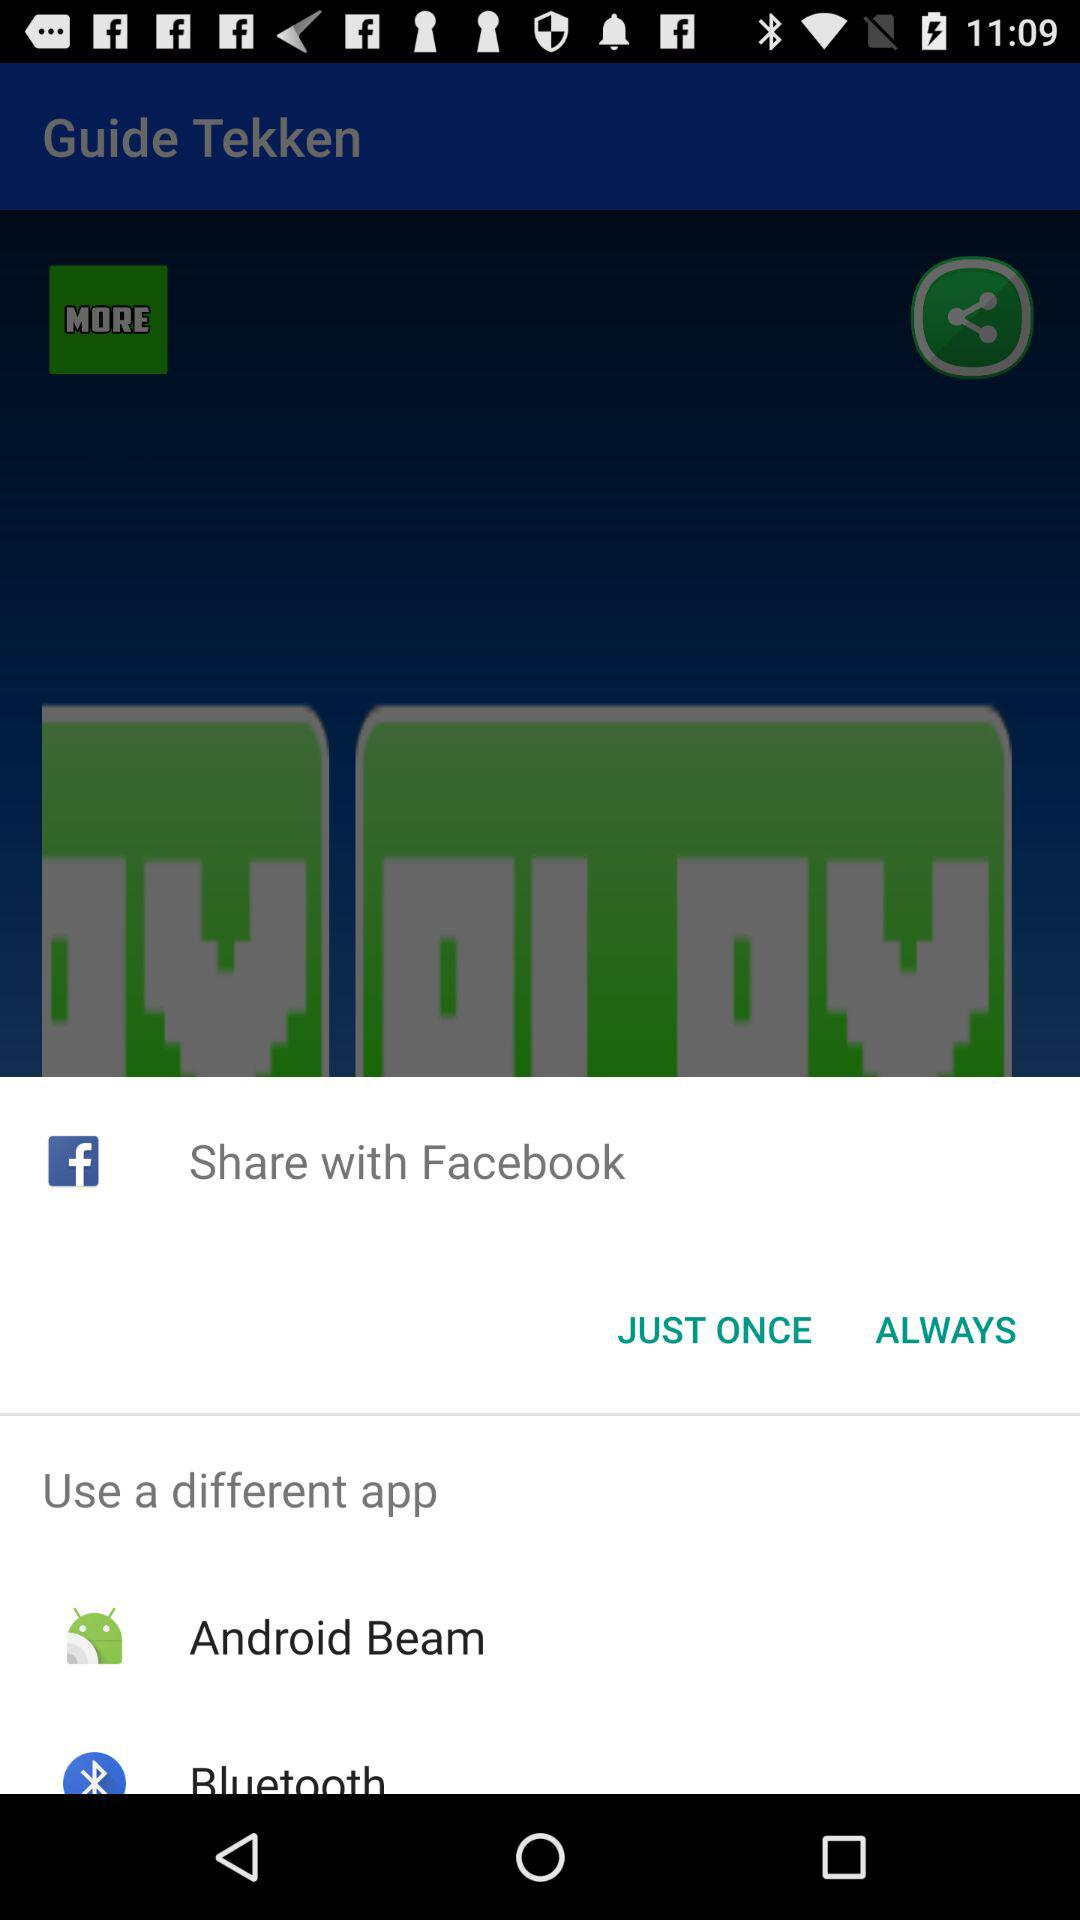Which character is the guide for?
When the provided information is insufficient, respond with <no answer>. <no answer> 